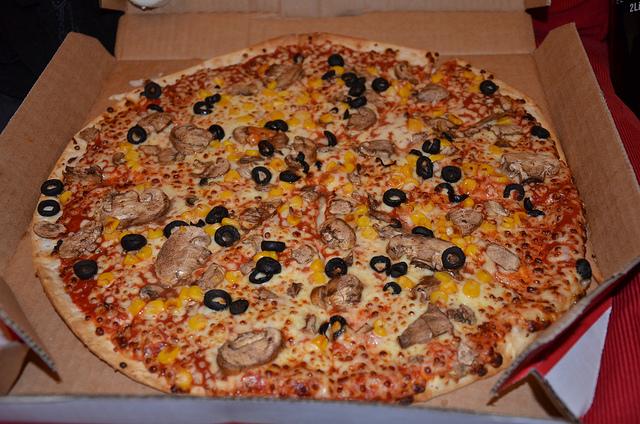Is the pizza sweet?
Answer briefly. No. How many people will eat this pizza?
Answer briefly. 3. Is that a pizza?
Keep it brief. Yes. What topping are on the pizza?
Write a very short answer. Olives. Was this a take out pizza?
Short answer required. Yes. What kind of pizza has been made?
Short answer required. Mushroom, olive, and pineapple. Are there onions on the pizza?
Be succinct. No. Is the pizza homemade?
Concise answer only. No. What type of pizza is this?
Concise answer only. Veggie. Are there artichoke hearts on the pizza?
Concise answer only. No. Did this come from the freezer?
Concise answer only. No. What topping is the pizza?
Answer briefly. Mushrooms and olives. This pizza serves how many people?
Keep it brief. 4. Is the pizza round?
Be succinct. Yes. Is it likely someone was distracted from watching this item cook?
Answer briefly. No. How many slices are missing from the pizza?
Be succinct. 0. Is this an Indian dish?
Short answer required. No. Is a whole pizza?
Concise answer only. Yes. What shape is the pizza box?
Keep it brief. Square. Would you be able to prepare such a dish?
Be succinct. Yes. What is the specific name of this particular pizza recipe?
Answer briefly. Vegetarian. Is there green sauce on the pizza?
Answer briefly. No. Is the food eaten?
Keep it brief. No. What are the pizza toppings?
Be succinct. Mushrooms, black olives, corn. 